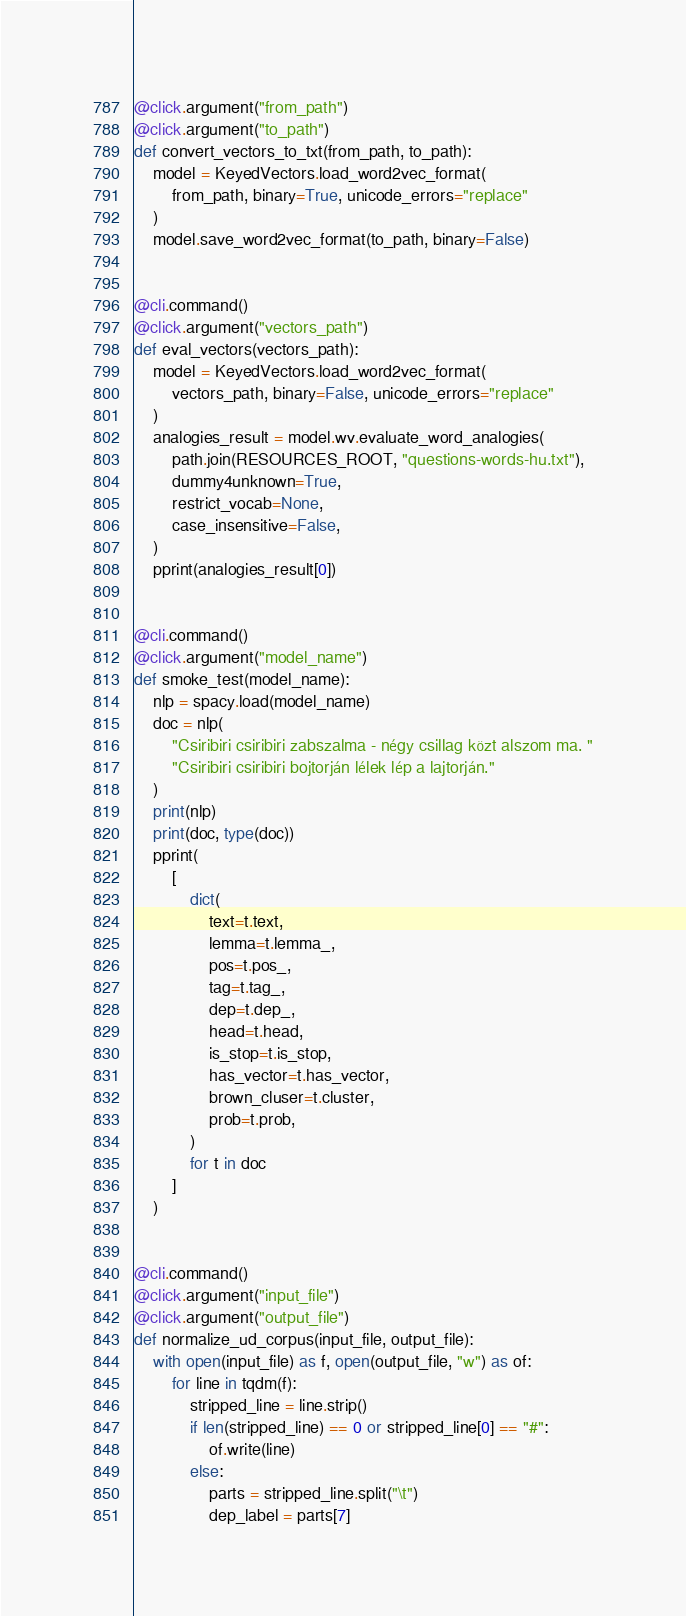Convert code to text. <code><loc_0><loc_0><loc_500><loc_500><_Python_>@click.argument("from_path")
@click.argument("to_path")
def convert_vectors_to_txt(from_path, to_path):
    model = KeyedVectors.load_word2vec_format(
        from_path, binary=True, unicode_errors="replace"
    )
    model.save_word2vec_format(to_path, binary=False)


@cli.command()
@click.argument("vectors_path")
def eval_vectors(vectors_path):
    model = KeyedVectors.load_word2vec_format(
        vectors_path, binary=False, unicode_errors="replace"
    )
    analogies_result = model.wv.evaluate_word_analogies(
        path.join(RESOURCES_ROOT, "questions-words-hu.txt"),
        dummy4unknown=True,
        restrict_vocab=None,
        case_insensitive=False,
    )
    pprint(analogies_result[0])


@cli.command()
@click.argument("model_name")
def smoke_test(model_name):
    nlp = spacy.load(model_name)
    doc = nlp(
        "Csiribiri csiribiri zabszalma - négy csillag közt alszom ma. "
        "Csiribiri csiribiri bojtorján lélek lép a lajtorján."
    )
    print(nlp)
    print(doc, type(doc))
    pprint(
        [
            dict(
                text=t.text,
                lemma=t.lemma_,
                pos=t.pos_,
                tag=t.tag_,
                dep=t.dep_,
                head=t.head,
                is_stop=t.is_stop,
                has_vector=t.has_vector,
                brown_cluser=t.cluster,
                prob=t.prob,
            )
            for t in doc
        ]
    )


@cli.command()
@click.argument("input_file")
@click.argument("output_file")
def normalize_ud_corpus(input_file, output_file):
    with open(input_file) as f, open(output_file, "w") as of:
        for line in tqdm(f):
            stripped_line = line.strip()
            if len(stripped_line) == 0 or stripped_line[0] == "#":
                of.write(line)
            else:
                parts = stripped_line.split("\t")
                dep_label = parts[7]</code> 